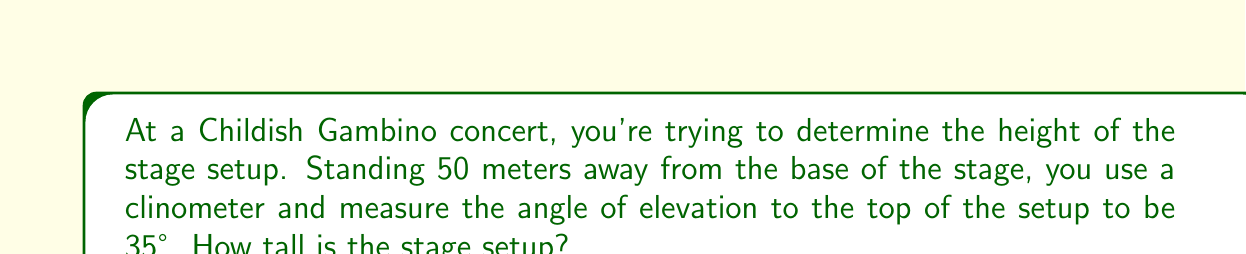Can you answer this question? Let's approach this step-by-step using trigonometry:

1) We can model this scenario as a right triangle, where:
   - The adjacent side is the distance from you to the base of the stage (50 meters)
   - The opposite side is the height of the stage setup (what we're trying to find)
   - The angle of elevation is 35°

2) In this case, we need to use the tangent ratio, as we're given the adjacent side and need to find the opposite side.

3) The tangent of an angle in a right triangle is defined as:

   $$\tan \theta = \frac{\text{opposite}}{\text{adjacent}}$$

4) Let's call the height of the stage setup $h$. We can set up the equation:

   $$\tan 35° = \frac{h}{50}$$

5) To solve for $h$, we multiply both sides by 50:

   $$50 \tan 35° = h$$

6) Now we can calculate:
   
   $$h = 50 \times \tan 35° \approx 50 \times 0.7002 \approx 35.01 \text{ meters}$$

[asy]
import geometry;

size(200);
pair A=(0,0), B=(100,0), C=(100,70);
draw(A--B--C--A);
draw(B--(90,0), arrow=Arrow(TeXHead));
draw((90,0)--(90,10), arrow=Arrow(TeXHead));
label("50 m", (50,0), S);
label("h", (103,35), E);
label("35°", (10,10), NW);
dot("You", A, SW);
dot("Stage", B, SE);
[/asy]
Answer: $35.01 \text{ meters}$ 